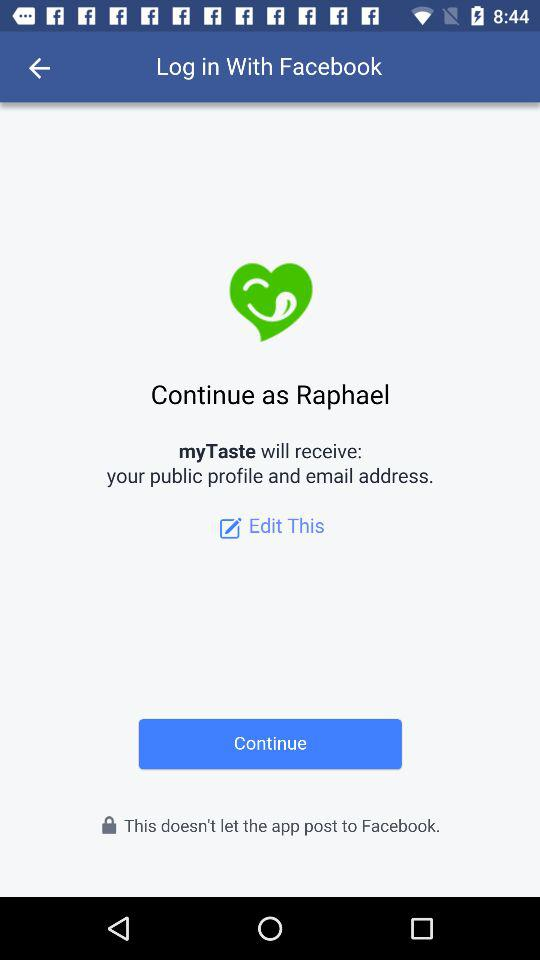How can we log in? You can log in with Facebook. 